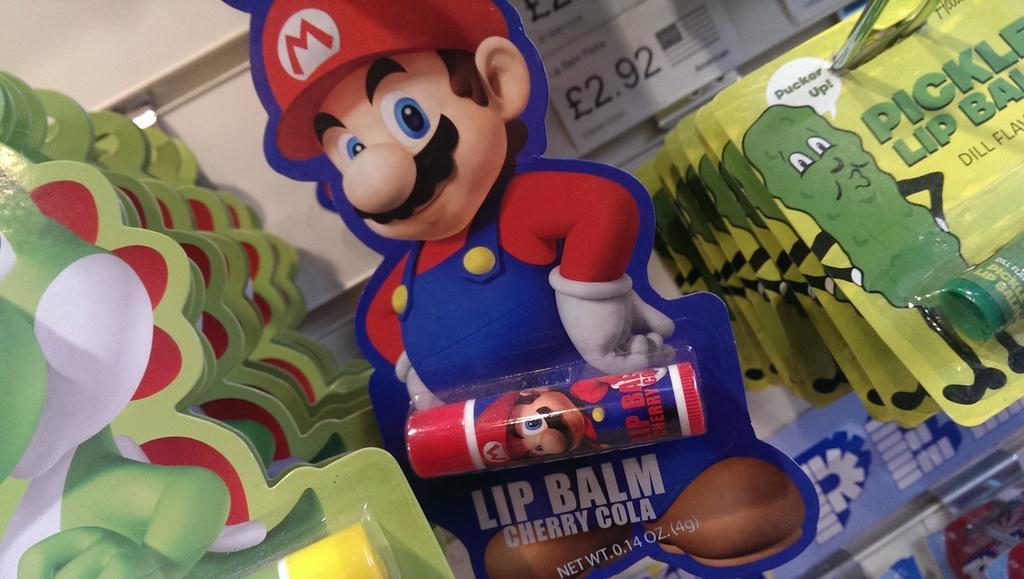Please provide a concise description of this image. In this image, I can see the lip balms, which are attached to the cartoon boards. These look like the price tags, which is attached to the wall. 